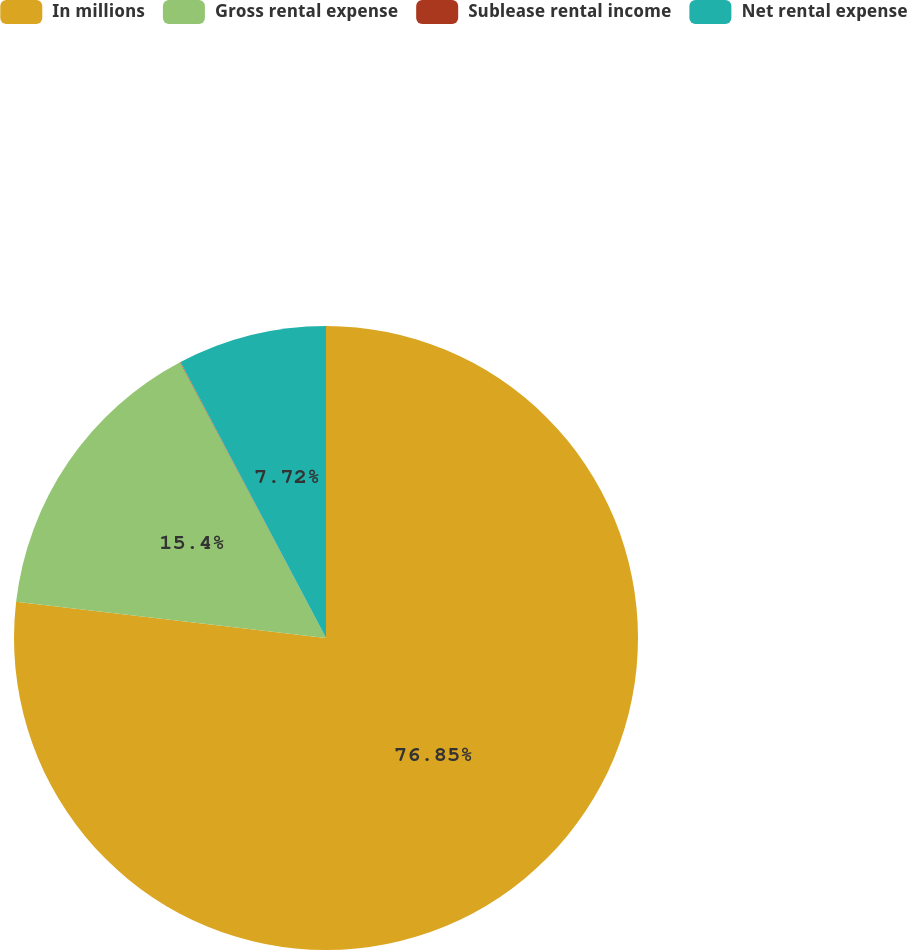Convert chart to OTSL. <chart><loc_0><loc_0><loc_500><loc_500><pie_chart><fcel>In millions<fcel>Gross rental expense<fcel>Sublease rental income<fcel>Net rental expense<nl><fcel>76.85%<fcel>15.4%<fcel>0.03%<fcel>7.72%<nl></chart> 